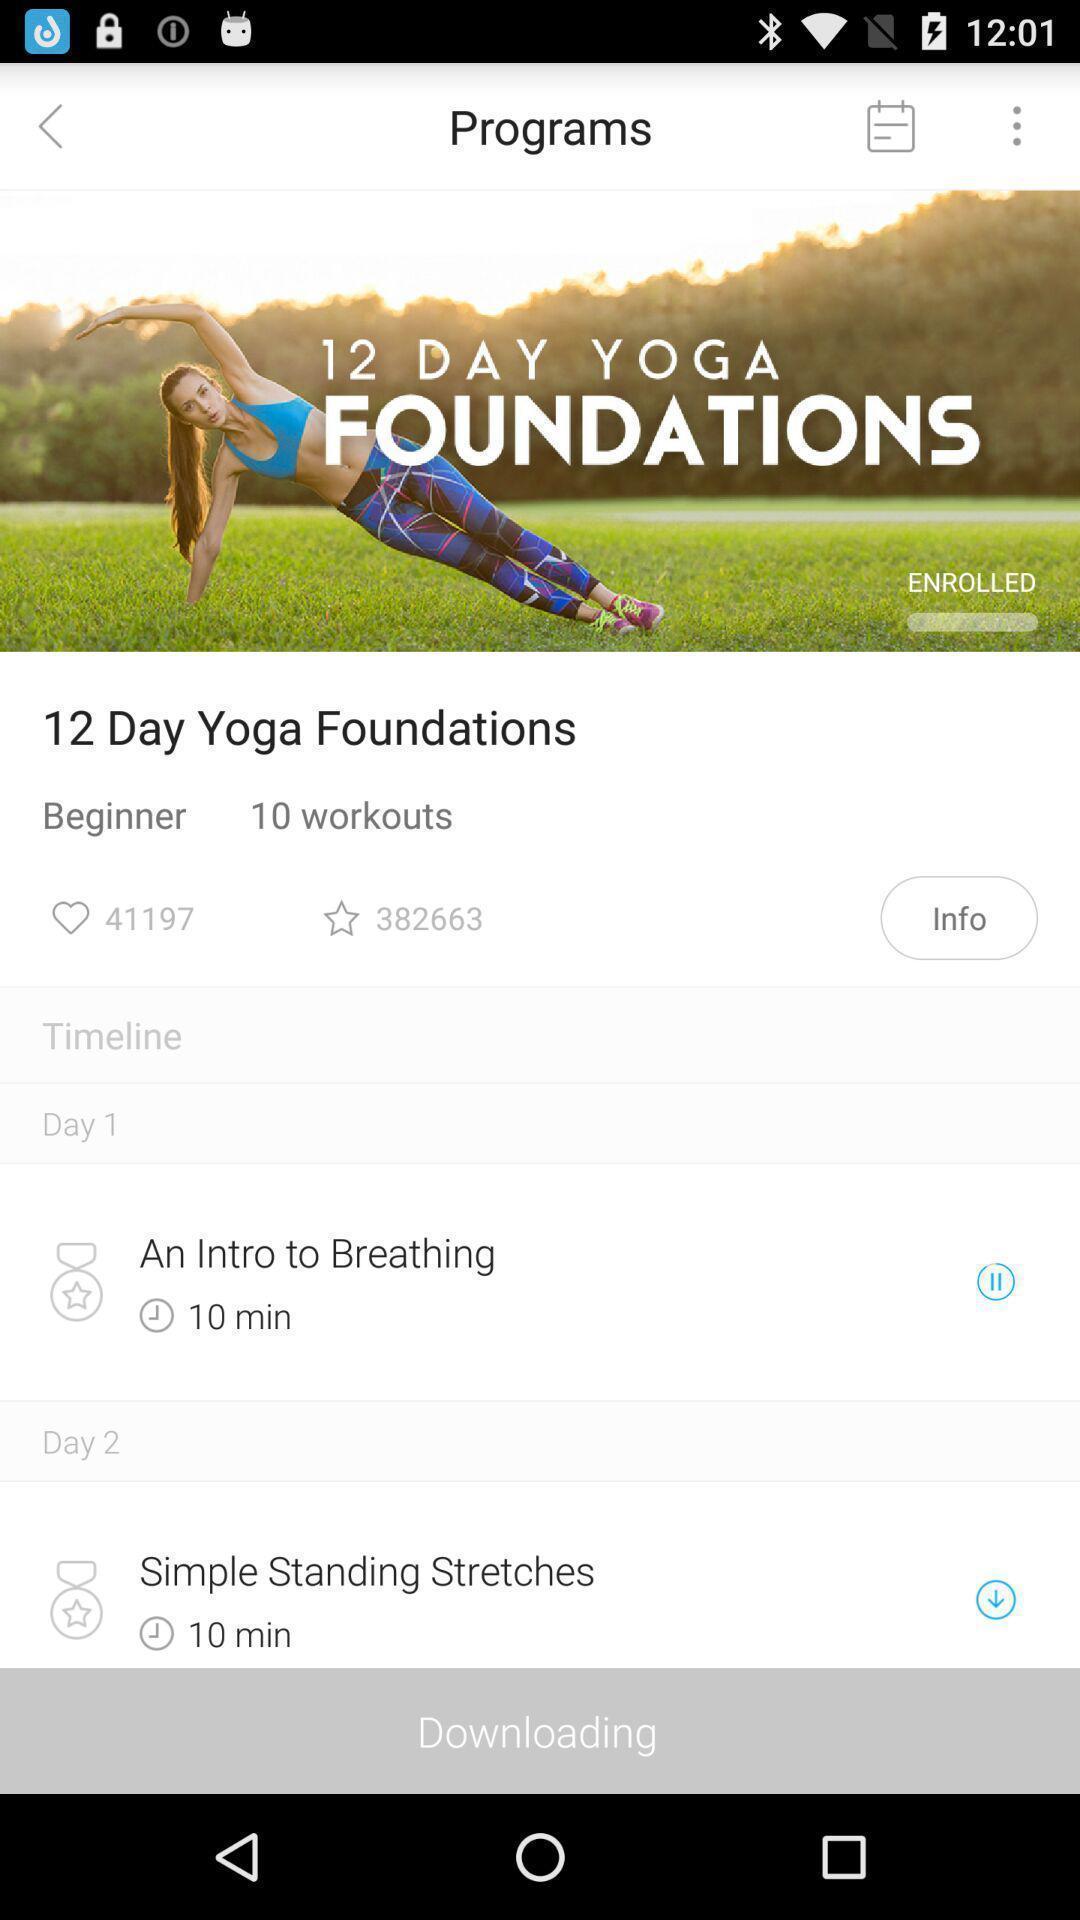Describe this image in words. Page showing information about yoga program. 